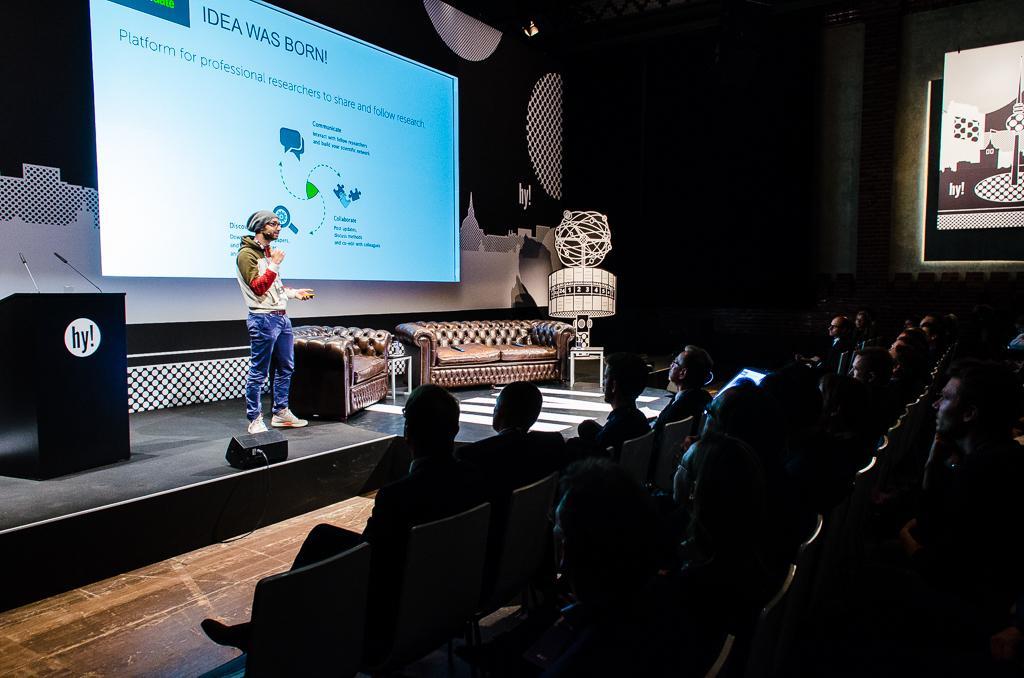Can you describe this image briefly? There are few people here sitting on the chairs and there is a man standing on the stage. We can also see a podium with microphones on it,sofas,stools and a screen and on the right at the top corner there is another screen. 